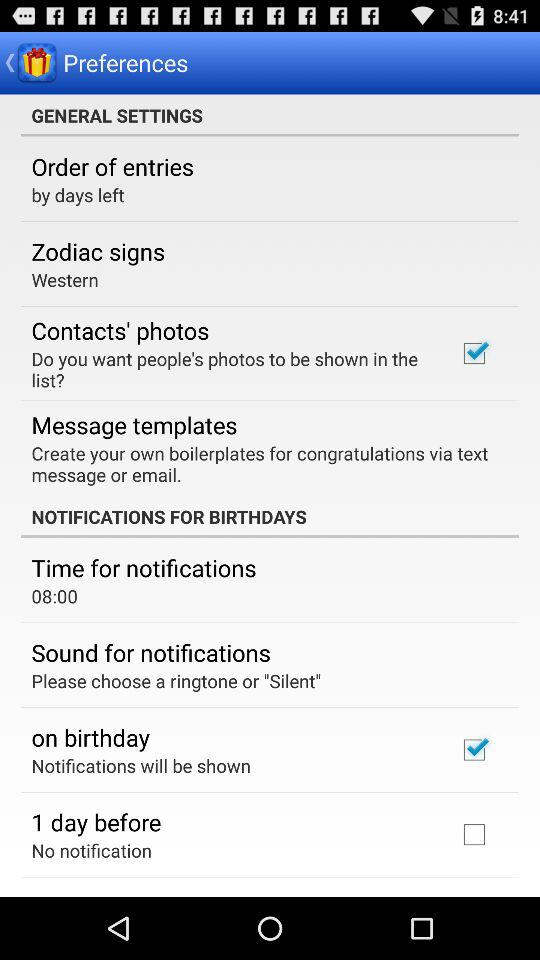How many items are in the Notifications for Birthdays section?
Answer the question using a single word or phrase. 4 